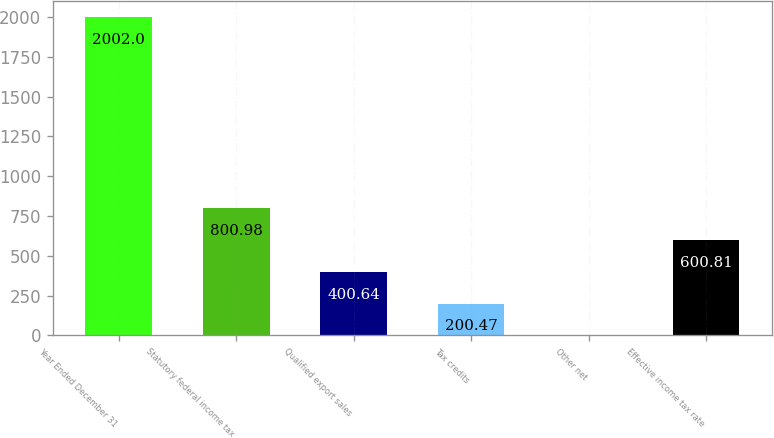Convert chart. <chart><loc_0><loc_0><loc_500><loc_500><bar_chart><fcel>Year Ended December 31<fcel>Statutory federal income tax<fcel>Qualified export sales<fcel>Tax credits<fcel>Other net<fcel>Effective income tax rate<nl><fcel>2002<fcel>800.98<fcel>400.64<fcel>200.47<fcel>0.3<fcel>600.81<nl></chart> 